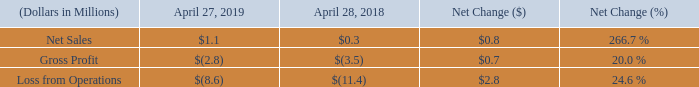Medical Segment Results
Below is a table summarizing results for the fiscal years ended:
Net Sales. The Medical segment had $1.1 million of net sales in fiscal 2019, compared to $0.3 million of net sales in fiscal 2018. The increase was due to new business gained in fiscal 2019.
Gross Profit. Medical segment gross profit was a loss of $2.8 million in fiscal 2019, compared to a loss of $3.5 million in fiscal 2018. The improvement primarily relates to an increase in sales volumes during fiscal 2019.
Loss from Operations. Medical segment loss from operations decreased $2.8 million to $8.6 million in fiscal 2019, compared to $11.4 million in fiscal 2018. The decrease was due to an improvement in gross profit and lower selling and administrative expenses. Selling and administrative expenses were reduced by lower marketing and professional fee expenses, partially offset by initiatives to reduce overall costs and improve operational profitability of $0.9 million.
What led to improvement in medical segment gross profit during fiscal 2019? An increase in sales volumes during fiscal 2019. What is the average Gross Profit for Fiscal Year Ended April 28, 2018 to Fiscal Year Ended April 27, 2019?
Answer scale should be: million. -(2.8+3.5) / 2
Answer: -3.15. What is the average Loss from Operations for Fiscal Year Ended April 28, 2018 to Fiscal Year Ended April 27, 2019?
Answer scale should be: million. -(8.6+11.4) / 2
Answer: -10. In which period was net sales less than 1.0 million? Locate and analyze net sales in row 2
answer: 2018. What was the Gross Profit in 2019 and 2018 respectively?
Answer scale should be: million. $(2.8), $(3.5). What was the net sales from medical segment in 2019? $1.1 million. 